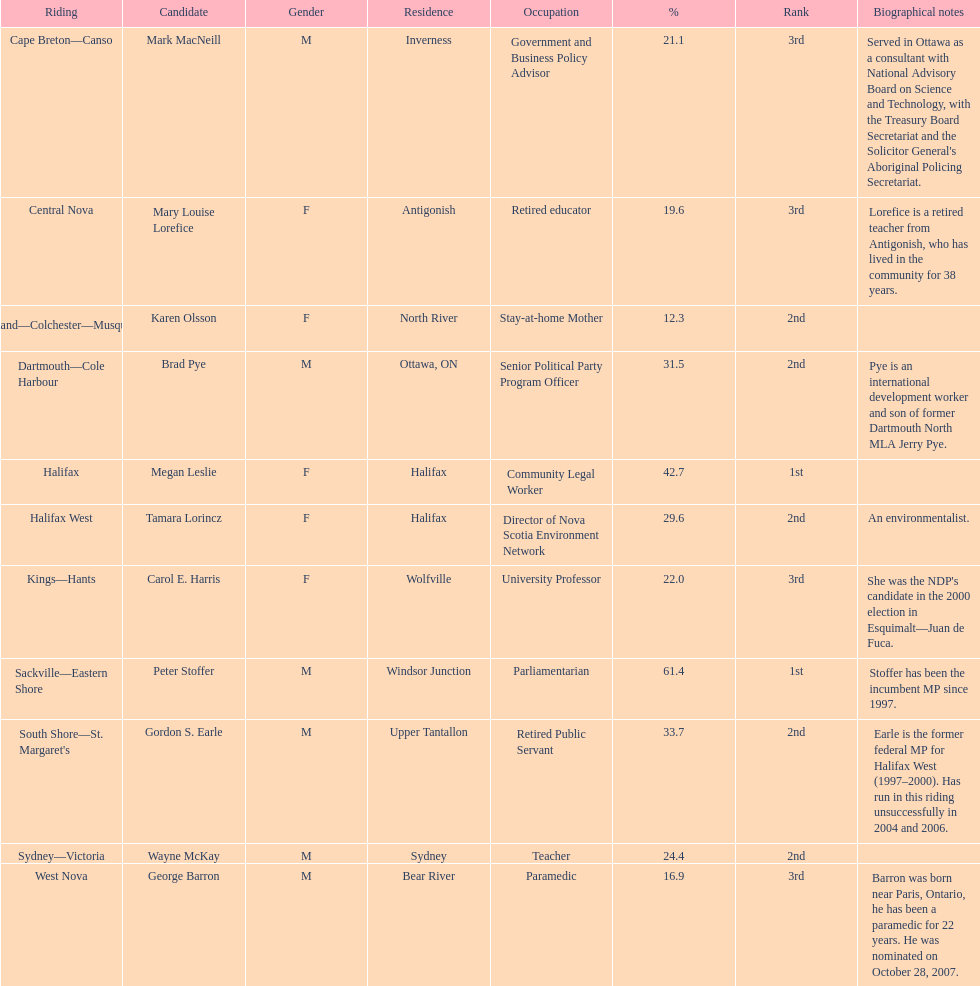What is the first riding? Cape Breton-Canso. 